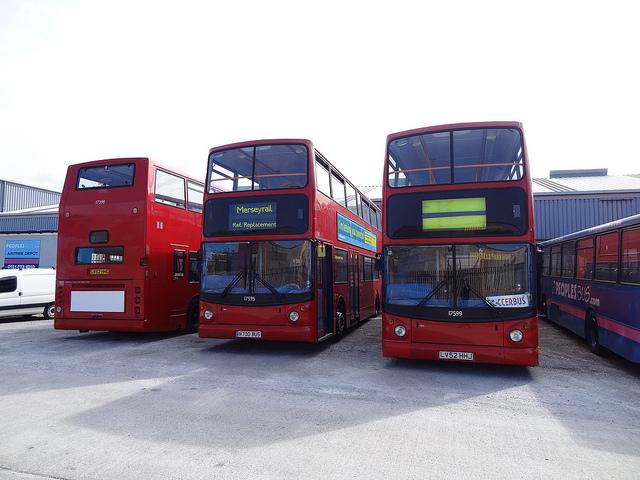What color vehicle is shown in this photo?
Be succinct. Red. How many levels these buses have?
Give a very brief answer. 2. Are these vehicles used for public transportation?
Keep it brief. Yes. 